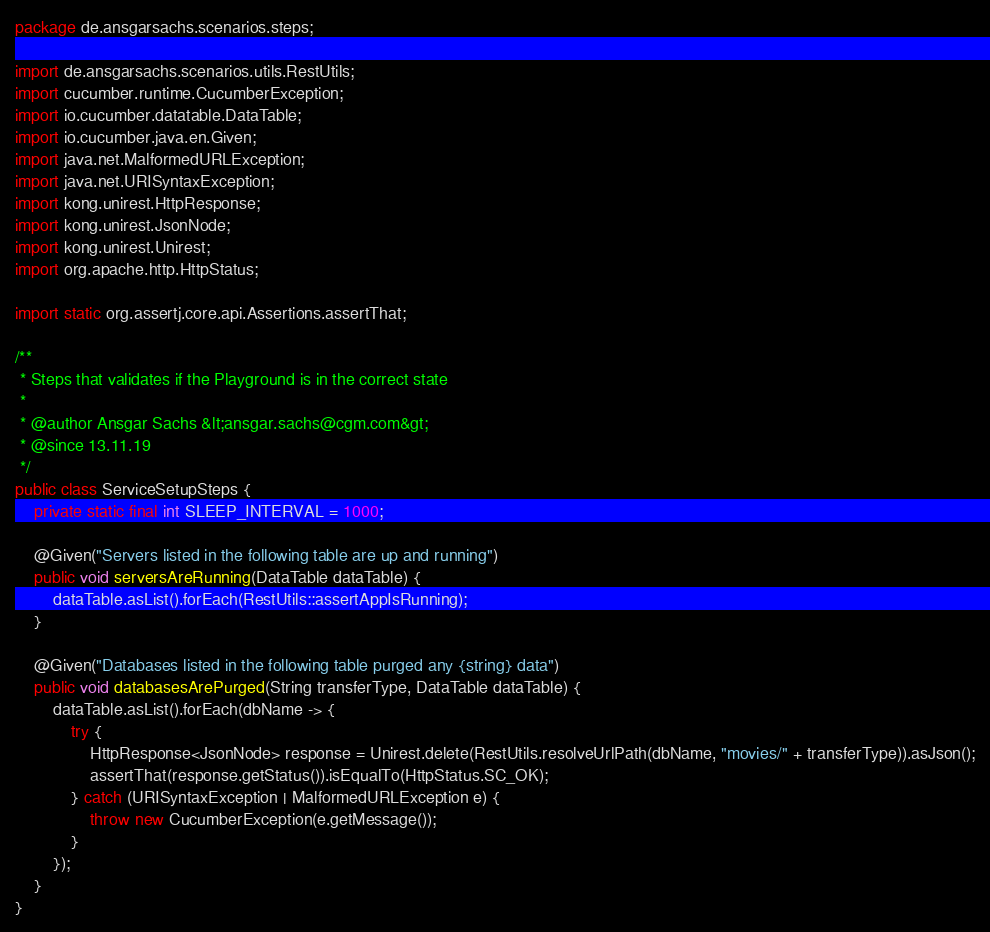<code> <loc_0><loc_0><loc_500><loc_500><_Java_>package de.ansgarsachs.scenarios.steps;

import de.ansgarsachs.scenarios.utils.RestUtils;
import cucumber.runtime.CucumberException;
import io.cucumber.datatable.DataTable;
import io.cucumber.java.en.Given;
import java.net.MalformedURLException;
import java.net.URISyntaxException;
import kong.unirest.HttpResponse;
import kong.unirest.JsonNode;
import kong.unirest.Unirest;
import org.apache.http.HttpStatus;

import static org.assertj.core.api.Assertions.assertThat;

/**
 * Steps that validates if the Playground is in the correct state
 *
 * @author Ansgar Sachs &lt;ansgar.sachs@cgm.com&gt;
 * @since 13.11.19
 */
public class ServiceSetupSteps {
    private static final int SLEEP_INTERVAL = 1000;

    @Given("Servers listed in the following table are up and running")
    public void serversAreRunning(DataTable dataTable) {
        dataTable.asList().forEach(RestUtils::assertAppIsRunning);
    }

    @Given("Databases listed in the following table purged any {string} data")
    public void databasesArePurged(String transferType, DataTable dataTable) {
        dataTable.asList().forEach(dbName -> {
            try {
                HttpResponse<JsonNode> response = Unirest.delete(RestUtils.resolveUrlPath(dbName, "movies/" + transferType)).asJson();
                assertThat(response.getStatus()).isEqualTo(HttpStatus.SC_OK);
            } catch (URISyntaxException | MalformedURLException e) {
                throw new CucumberException(e.getMessage());
            }
        });
    }
}
</code> 